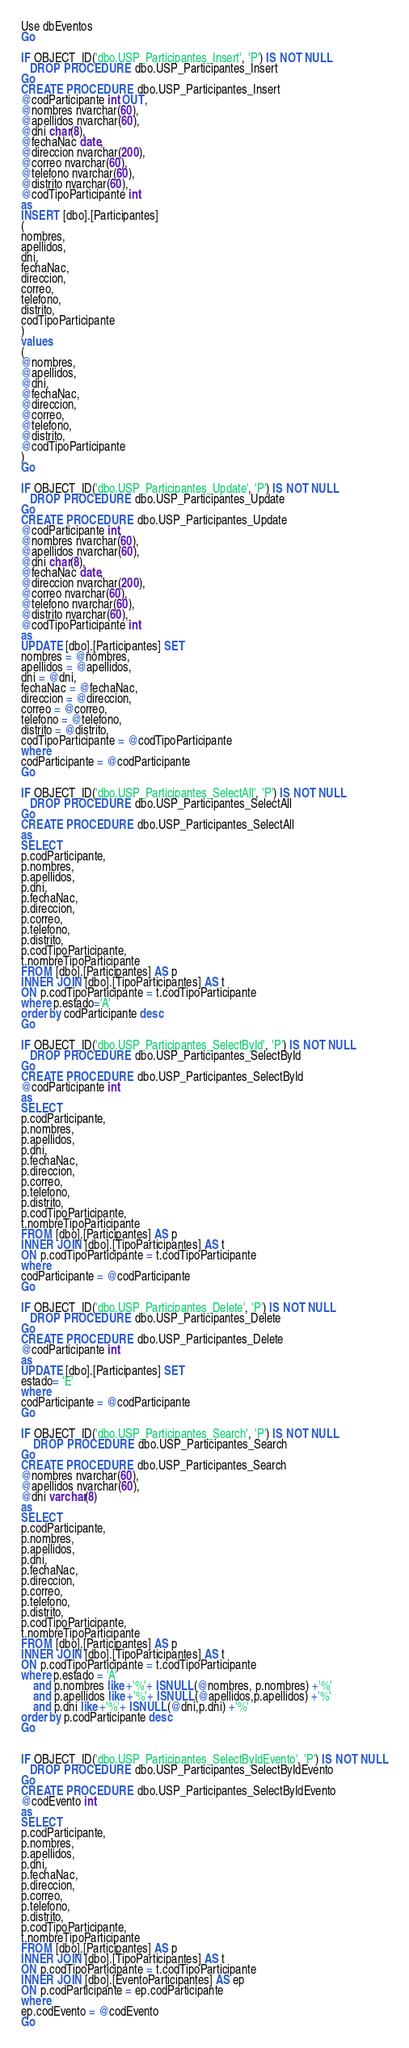Convert code to text. <code><loc_0><loc_0><loc_500><loc_500><_SQL_>
Use dbEventos
Go

IF OBJECT_ID('dbo.USP_Participantes_Insert', 'P') IS NOT NULL
   DROP PROCEDURE dbo.USP_Participantes_Insert
Go
CREATE PROCEDURE dbo.USP_Participantes_Insert
@codParticipante int OUT,
@nombres nvarchar(60),
@apellidos nvarchar(60),
@dni char(8),
@fechaNac date,
@direccion nvarchar(200),
@correo nvarchar(60),
@telefono nvarchar(60),
@distrito nvarchar(60),
@codTipoParticipante int
as
INSERT [dbo].[Participantes]
(
nombres,
apellidos,
dni,
fechaNac,
direccion,
correo,
telefono,
distrito,
codTipoParticipante
)
values
(
@nombres,
@apellidos,
@dni,
@fechaNac,
@direccion,
@correo,
@telefono,
@distrito,
@codTipoParticipante
)
Go

IF OBJECT_ID('dbo.USP_Participantes_Update', 'P') IS NOT NULL
   DROP PROCEDURE dbo.USP_Participantes_Update
Go
CREATE PROCEDURE dbo.USP_Participantes_Update
@codParticipante int,
@nombres nvarchar(60),
@apellidos nvarchar(60),
@dni char(8),
@fechaNac date,
@direccion nvarchar(200),
@correo nvarchar(60),
@telefono nvarchar(60),
@distrito nvarchar(60),
@codTipoParticipante int
as
UPDATE [dbo].[Participantes] SET 
nombres = @nombres,
apellidos = @apellidos,
dni = @dni,
fechaNac = @fechaNac,
direccion = @direccion,
correo = @correo,
telefono = @telefono,
distrito = @distrito,
codTipoParticipante = @codTipoParticipante
where
codParticipante = @codParticipante
Go

IF OBJECT_ID('dbo.USP_Participantes_SelectAll', 'P') IS NOT NULL
   DROP PROCEDURE dbo.USP_Participantes_SelectAll
Go
CREATE PROCEDURE dbo.USP_Participantes_SelectAll
as
SELECT
p.codParticipante,
p.nombres,
p.apellidos,
p.dni,
p.fechaNac,
p.direccion,
p.correo,
p.telefono,
p.distrito,
p.codTipoParticipante,
t.nombreTipoParticipante
FROM [dbo].[Participantes] AS p
INNER JOIN [dbo].[TipoParticipantes] AS t
ON p.codTipoParticipante = t.codTipoParticipante
where p.estado='A'
order by codParticipante desc
Go 

IF OBJECT_ID('dbo.USP_Participantes_SelectById', 'P') IS NOT NULL
   DROP PROCEDURE dbo.USP_Participantes_SelectById
Go
CREATE PROCEDURE dbo.USP_Participantes_SelectById
@codParticipante int
as
SELECT
p.codParticipante,
p.nombres,
p.apellidos,
p.dni,
p.fechaNac,
p.direccion,
p.correo,
p.telefono,
p.distrito,
p.codTipoParticipante,
t.nombreTipoParticipante
FROM [dbo].[Participantes] AS p
INNER JOIN [dbo].[TipoParticipantes] AS t
ON p.codTipoParticipante = t.codTipoParticipante
where
codParticipante = @codParticipante
Go

IF OBJECT_ID('dbo.USP_Participantes_Delete', 'P') IS NOT NULL
   DROP PROCEDURE dbo.USP_Participantes_Delete
Go
CREATE PROCEDURE dbo.USP_Participantes_Delete
@codParticipante int
as
UPDATE [dbo].[Participantes] SET
estado= 'E'
where
codParticipante = @codParticipante
Go

IF OBJECT_ID('dbo.USP_Participantes_Search', 'P') IS NOT NULL
	DROP PROCEDURE dbo.USP_Participantes_Search
Go
CREATE PROCEDURE dbo.USP_Participantes_Search
@nombres nvarchar(60),
@apellidos nvarchar(60),
@dni varchar(8)
as
SELECT
p.codParticipante,
p.nombres,
p.apellidos,
p.dni,
p.fechaNac,
p.direccion,
p.correo,
p.telefono,
p.distrito,
p.codTipoParticipante,
t.nombreTipoParticipante
FROM [dbo].[Participantes] AS p
INNER JOIN [dbo].[TipoParticipantes] AS t
ON p.codTipoParticipante = t.codTipoParticipante
where p.estado = 'A'
	and p.nombres like +'%'+ ISNULL(@nombres, p.nombres) +'%'
	and p.apellidos like +'%'+ ISNULL(@apellidos,p.apellidos) +'%'
	and p.dni like +'%'+ ISNULL(@dni,p.dni) +'%'
order by p.codParticipante desc
Go


IF OBJECT_ID('dbo.USP_Participantes_SelectByIdEvento', 'P') IS NOT NULL
   DROP PROCEDURE dbo.USP_Participantes_SelectByIdEvento
Go
CREATE PROCEDURE dbo.USP_Participantes_SelectByIdEvento
@codEvento int
as
SELECT
p.codParticipante,
p.nombres,
p.apellidos,
p.dni,
p.fechaNac,
p.direccion,
p.correo,
p.telefono,
p.distrito,
p.codTipoParticipante,
t.nombreTipoParticipante
FROM [dbo].[Participantes] AS p
INNER JOIN [dbo].[TipoParticipantes] AS t
ON p.codTipoParticipante = t.codTipoParticipante
INNER JOIN [dbo].[EventoParticipantes] AS ep
ON p.codParticipante = ep.codParticipante
where
ep.codEvento = @codEvento
Go</code> 